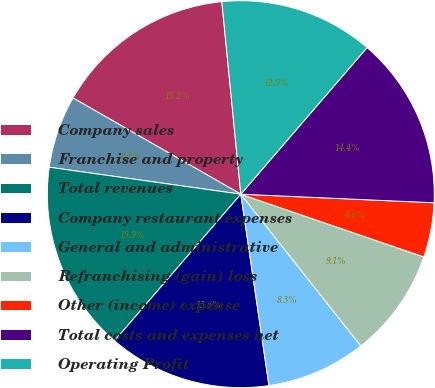Convert chart to OTSL. <chart><loc_0><loc_0><loc_500><loc_500><pie_chart><fcel>Company sales<fcel>Franchise and property<fcel>Total revenues<fcel>Company restaurant expenses<fcel>General and administrative<fcel>Refranchising (gain) loss<fcel>Other (income) expense<fcel>Total costs and expenses net<fcel>Operating Profit<nl><fcel>15.15%<fcel>6.06%<fcel>15.91%<fcel>13.64%<fcel>8.33%<fcel>9.09%<fcel>4.55%<fcel>14.39%<fcel>12.88%<nl></chart> 